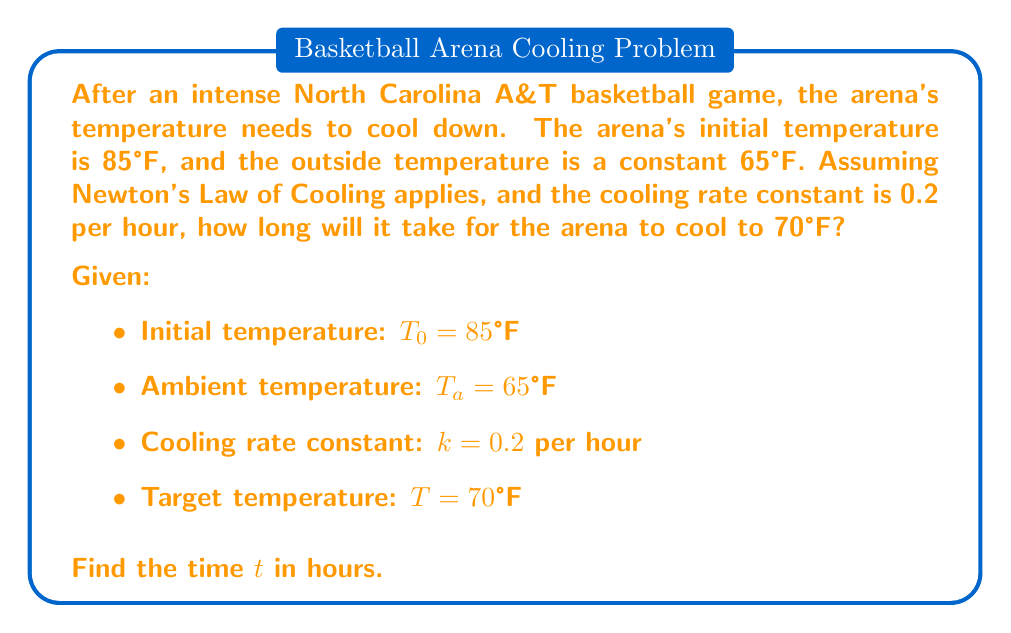Give your solution to this math problem. Let's solve this step-by-step using Newton's Law of Cooling:

1) Newton's Law of Cooling is given by the differential equation:
   
   $$\frac{dT}{dt} = -k(T - T_a)$$

2) The solution to this equation is:
   
   $$T(t) = T_a + (T_0 - T_a)e^{-kt}$$

3) We want to find $t$ when $T(t) = 70°F$. Let's substitute our known values:

   $$70 = 65 + (85 - 65)e^{-0.2t}$$

4) Simplify:
   
   $$70 = 65 + 20e^{-0.2t}$$

5) Subtract 65 from both sides:
   
   $$5 = 20e^{-0.2t}$$

6) Divide both sides by 20:
   
   $$0.25 = e^{-0.2t}$$

7) Take the natural logarithm of both sides:
   
   $$\ln(0.25) = -0.2t$$

8) Solve for $t$:
   
   $$t = -\frac{\ln(0.25)}{0.2} = \frac{\ln(4)}{0.2} \approx 6.93$$

Therefore, it will take approximately 6.93 hours for the arena to cool to 70°F.
Answer: $t \approx 6.93$ hours 